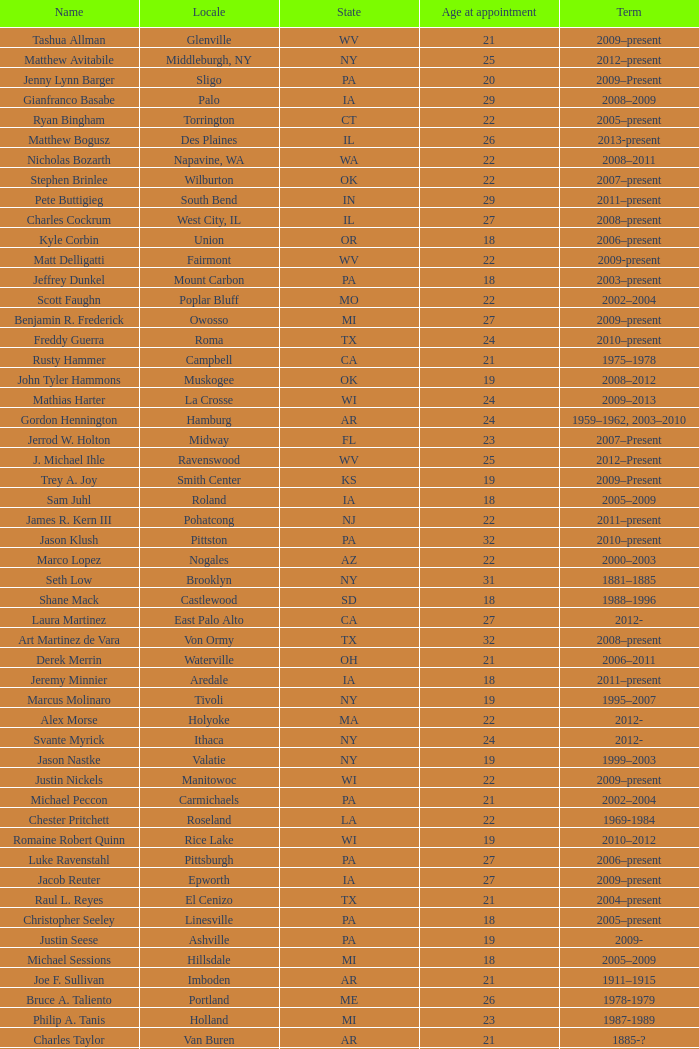What is the title of the dutch location? Philip A. Tanis. 